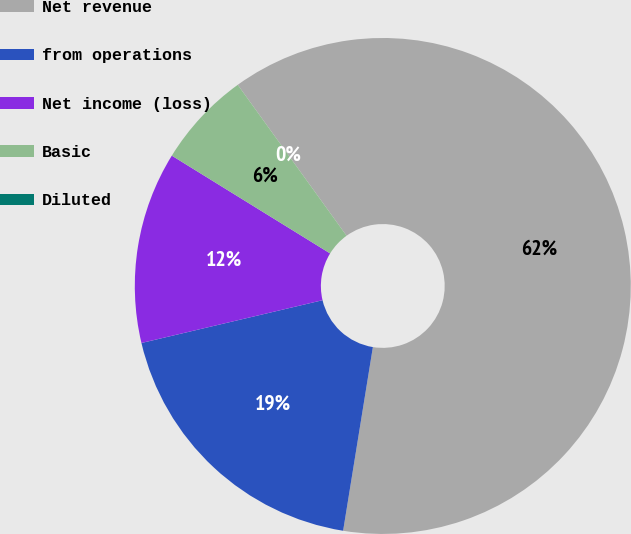<chart> <loc_0><loc_0><loc_500><loc_500><pie_chart><fcel>Net revenue<fcel>from operations<fcel>Net income (loss)<fcel>Basic<fcel>Diluted<nl><fcel>62.5%<fcel>18.75%<fcel>12.5%<fcel>6.25%<fcel>0.0%<nl></chart> 